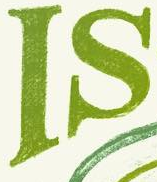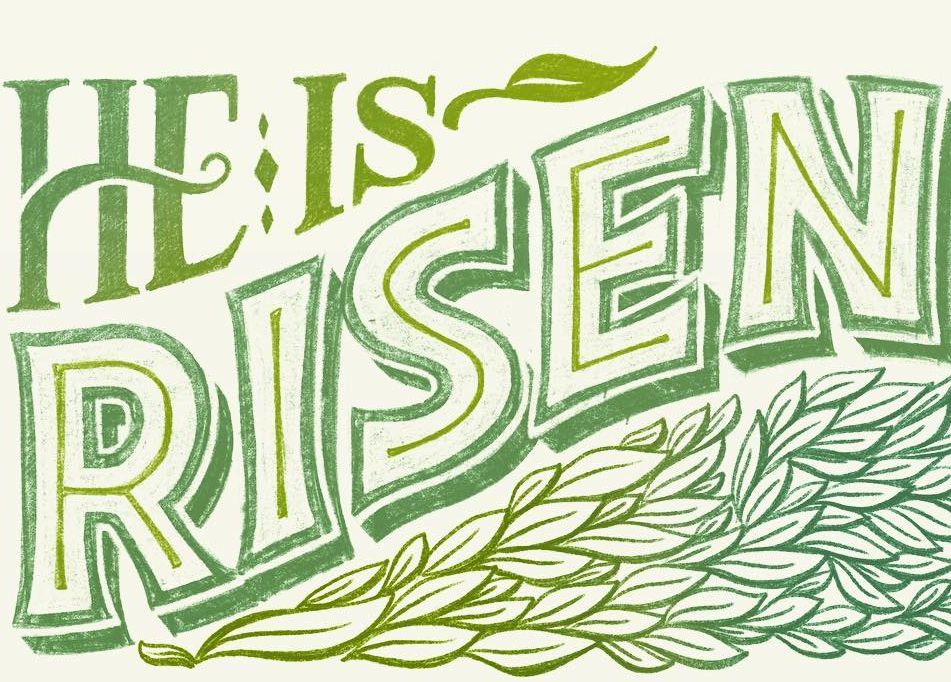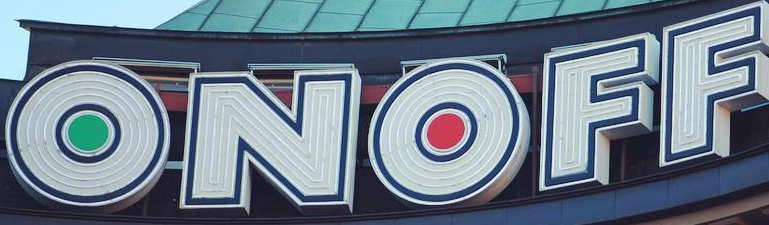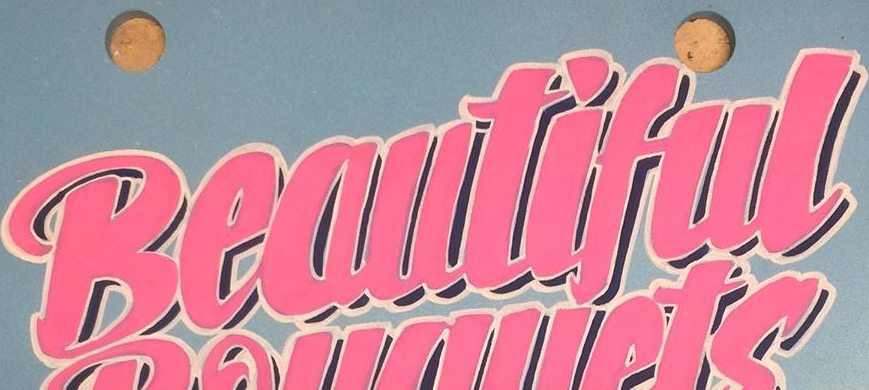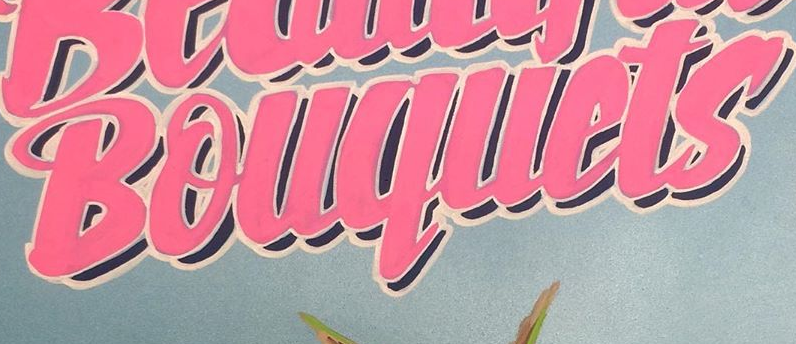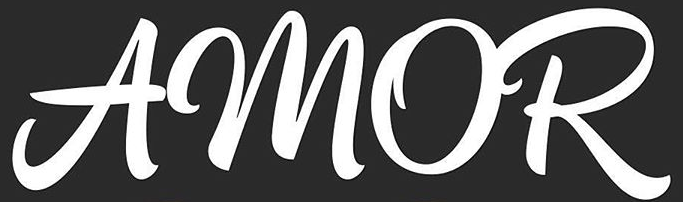Transcribe the words shown in these images in order, separated by a semicolon. IS; RISEN; ONOFF; Beautiful; Bouquets; AMOR 